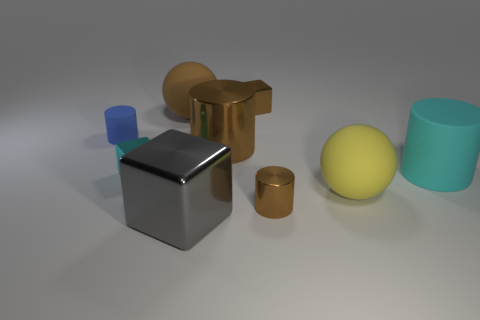There is a metal block that is behind the rubber cylinder that is to the left of the cyan object that is left of the cyan rubber cylinder; what is its size?
Offer a terse response. Small. What is the material of the tiny cube that is the same color as the big metallic cylinder?
Keep it short and to the point. Metal. What size is the blue cylinder?
Provide a succinct answer. Small. What is the shape of the metal object that is behind the large brown rubber object?
Offer a terse response. Cube. There is a small brown thing that is made of the same material as the tiny brown block; what is its shape?
Give a very brief answer. Cylinder. Is there anything else that is the same shape as the yellow matte object?
Your response must be concise. Yes. There is a brown cube; what number of matte balls are to the right of it?
Your response must be concise. 1. Is the number of brown matte things that are behind the small brown block the same as the number of big blue objects?
Offer a terse response. Yes. Is the material of the blue cylinder the same as the brown cube?
Ensure brevity in your answer.  No. How big is the object that is left of the brown ball and behind the cyan cube?
Provide a succinct answer. Small. 